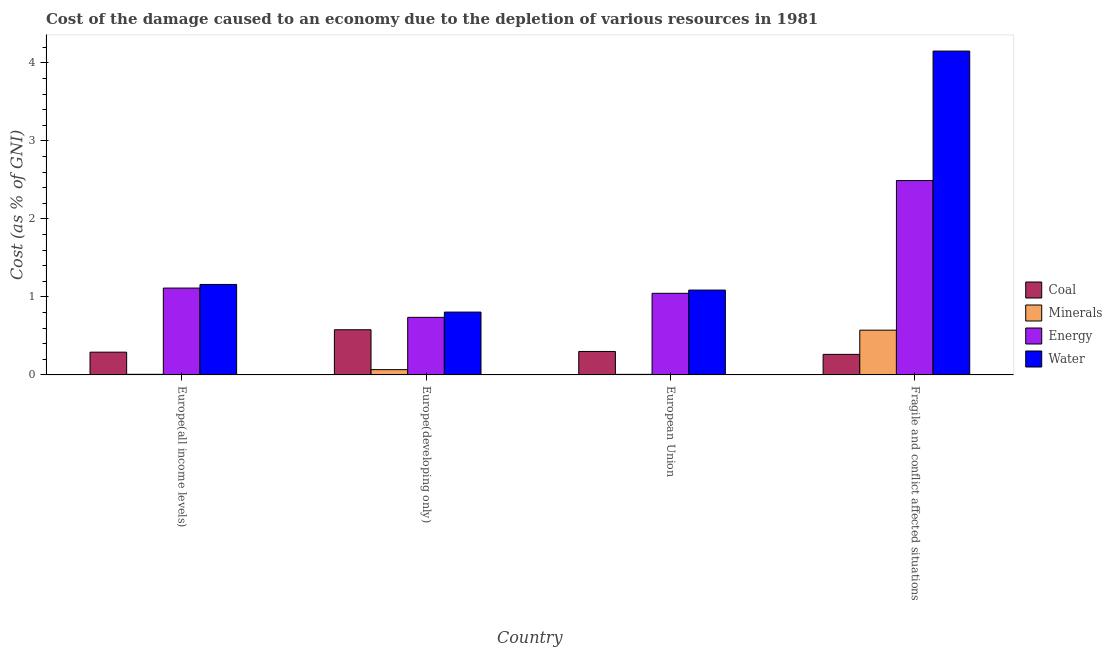How many different coloured bars are there?
Provide a short and direct response. 4. Are the number of bars per tick equal to the number of legend labels?
Keep it short and to the point. Yes. Are the number of bars on each tick of the X-axis equal?
Ensure brevity in your answer.  Yes. How many bars are there on the 1st tick from the left?
Offer a very short reply. 4. What is the label of the 3rd group of bars from the left?
Your answer should be compact. European Union. In how many cases, is the number of bars for a given country not equal to the number of legend labels?
Your answer should be compact. 0. What is the cost of damage due to depletion of coal in Europe(developing only)?
Offer a very short reply. 0.58. Across all countries, what is the maximum cost of damage due to depletion of energy?
Keep it short and to the point. 2.49. Across all countries, what is the minimum cost of damage due to depletion of minerals?
Your answer should be compact. 0.01. In which country was the cost of damage due to depletion of water maximum?
Ensure brevity in your answer.  Fragile and conflict affected situations. In which country was the cost of damage due to depletion of energy minimum?
Give a very brief answer. Europe(developing only). What is the total cost of damage due to depletion of energy in the graph?
Keep it short and to the point. 5.39. What is the difference between the cost of damage due to depletion of coal in Europe(all income levels) and that in Europe(developing only)?
Your response must be concise. -0.29. What is the difference between the cost of damage due to depletion of energy in Europe(developing only) and the cost of damage due to depletion of coal in Fragile and conflict affected situations?
Provide a short and direct response. 0.47. What is the average cost of damage due to depletion of coal per country?
Make the answer very short. 0.36. What is the difference between the cost of damage due to depletion of water and cost of damage due to depletion of energy in European Union?
Give a very brief answer. 0.04. What is the ratio of the cost of damage due to depletion of coal in Europe(all income levels) to that in Fragile and conflict affected situations?
Make the answer very short. 1.11. Is the cost of damage due to depletion of minerals in Europe(developing only) less than that in European Union?
Your response must be concise. No. What is the difference between the highest and the second highest cost of damage due to depletion of water?
Give a very brief answer. 2.99. What is the difference between the highest and the lowest cost of damage due to depletion of coal?
Offer a very short reply. 0.32. Is it the case that in every country, the sum of the cost of damage due to depletion of water and cost of damage due to depletion of coal is greater than the sum of cost of damage due to depletion of minerals and cost of damage due to depletion of energy?
Keep it short and to the point. Yes. What does the 4th bar from the left in European Union represents?
Your answer should be compact. Water. What does the 1st bar from the right in Europe(developing only) represents?
Give a very brief answer. Water. How many bars are there?
Your response must be concise. 16. Are all the bars in the graph horizontal?
Your answer should be compact. No. How many countries are there in the graph?
Give a very brief answer. 4. Are the values on the major ticks of Y-axis written in scientific E-notation?
Provide a short and direct response. No. Does the graph contain any zero values?
Your answer should be compact. No. Does the graph contain grids?
Provide a succinct answer. No. Where does the legend appear in the graph?
Your answer should be compact. Center right. What is the title of the graph?
Offer a very short reply. Cost of the damage caused to an economy due to the depletion of various resources in 1981 . What is the label or title of the X-axis?
Keep it short and to the point. Country. What is the label or title of the Y-axis?
Give a very brief answer. Cost (as % of GNI). What is the Cost (as % of GNI) of Coal in Europe(all income levels)?
Make the answer very short. 0.29. What is the Cost (as % of GNI) in Minerals in Europe(all income levels)?
Your answer should be compact. 0.01. What is the Cost (as % of GNI) in Energy in Europe(all income levels)?
Ensure brevity in your answer.  1.11. What is the Cost (as % of GNI) of Water in Europe(all income levels)?
Give a very brief answer. 1.16. What is the Cost (as % of GNI) of Coal in Europe(developing only)?
Provide a short and direct response. 0.58. What is the Cost (as % of GNI) of Minerals in Europe(developing only)?
Ensure brevity in your answer.  0.07. What is the Cost (as % of GNI) of Energy in Europe(developing only)?
Make the answer very short. 0.74. What is the Cost (as % of GNI) in Water in Europe(developing only)?
Your answer should be very brief. 0.81. What is the Cost (as % of GNI) in Coal in European Union?
Make the answer very short. 0.3. What is the Cost (as % of GNI) in Minerals in European Union?
Provide a succinct answer. 0.01. What is the Cost (as % of GNI) in Energy in European Union?
Ensure brevity in your answer.  1.05. What is the Cost (as % of GNI) of Water in European Union?
Keep it short and to the point. 1.09. What is the Cost (as % of GNI) of Coal in Fragile and conflict affected situations?
Provide a short and direct response. 0.26. What is the Cost (as % of GNI) of Minerals in Fragile and conflict affected situations?
Provide a succinct answer. 0.57. What is the Cost (as % of GNI) in Energy in Fragile and conflict affected situations?
Keep it short and to the point. 2.49. What is the Cost (as % of GNI) of Water in Fragile and conflict affected situations?
Provide a short and direct response. 4.15. Across all countries, what is the maximum Cost (as % of GNI) of Coal?
Keep it short and to the point. 0.58. Across all countries, what is the maximum Cost (as % of GNI) in Minerals?
Your answer should be very brief. 0.57. Across all countries, what is the maximum Cost (as % of GNI) in Energy?
Provide a succinct answer. 2.49. Across all countries, what is the maximum Cost (as % of GNI) of Water?
Give a very brief answer. 4.15. Across all countries, what is the minimum Cost (as % of GNI) of Coal?
Provide a short and direct response. 0.26. Across all countries, what is the minimum Cost (as % of GNI) in Minerals?
Ensure brevity in your answer.  0.01. Across all countries, what is the minimum Cost (as % of GNI) in Energy?
Provide a succinct answer. 0.74. Across all countries, what is the minimum Cost (as % of GNI) in Water?
Give a very brief answer. 0.81. What is the total Cost (as % of GNI) of Coal in the graph?
Your response must be concise. 1.43. What is the total Cost (as % of GNI) in Minerals in the graph?
Offer a terse response. 0.66. What is the total Cost (as % of GNI) in Energy in the graph?
Your answer should be very brief. 5.39. What is the total Cost (as % of GNI) in Water in the graph?
Keep it short and to the point. 7.21. What is the difference between the Cost (as % of GNI) of Coal in Europe(all income levels) and that in Europe(developing only)?
Give a very brief answer. -0.29. What is the difference between the Cost (as % of GNI) of Minerals in Europe(all income levels) and that in Europe(developing only)?
Offer a terse response. -0.06. What is the difference between the Cost (as % of GNI) of Energy in Europe(all income levels) and that in Europe(developing only)?
Your answer should be very brief. 0.38. What is the difference between the Cost (as % of GNI) of Water in Europe(all income levels) and that in Europe(developing only)?
Ensure brevity in your answer.  0.35. What is the difference between the Cost (as % of GNI) of Coal in Europe(all income levels) and that in European Union?
Keep it short and to the point. -0.01. What is the difference between the Cost (as % of GNI) in Minerals in Europe(all income levels) and that in European Union?
Give a very brief answer. 0. What is the difference between the Cost (as % of GNI) of Energy in Europe(all income levels) and that in European Union?
Provide a short and direct response. 0.07. What is the difference between the Cost (as % of GNI) in Water in Europe(all income levels) and that in European Union?
Provide a succinct answer. 0.07. What is the difference between the Cost (as % of GNI) in Coal in Europe(all income levels) and that in Fragile and conflict affected situations?
Offer a very short reply. 0.03. What is the difference between the Cost (as % of GNI) in Minerals in Europe(all income levels) and that in Fragile and conflict affected situations?
Your answer should be very brief. -0.57. What is the difference between the Cost (as % of GNI) of Energy in Europe(all income levels) and that in Fragile and conflict affected situations?
Your answer should be compact. -1.38. What is the difference between the Cost (as % of GNI) of Water in Europe(all income levels) and that in Fragile and conflict affected situations?
Offer a very short reply. -2.99. What is the difference between the Cost (as % of GNI) of Coal in Europe(developing only) and that in European Union?
Your response must be concise. 0.28. What is the difference between the Cost (as % of GNI) in Minerals in Europe(developing only) and that in European Union?
Make the answer very short. 0.06. What is the difference between the Cost (as % of GNI) of Energy in Europe(developing only) and that in European Union?
Keep it short and to the point. -0.31. What is the difference between the Cost (as % of GNI) of Water in Europe(developing only) and that in European Union?
Ensure brevity in your answer.  -0.28. What is the difference between the Cost (as % of GNI) in Coal in Europe(developing only) and that in Fragile and conflict affected situations?
Provide a short and direct response. 0.32. What is the difference between the Cost (as % of GNI) of Minerals in Europe(developing only) and that in Fragile and conflict affected situations?
Offer a very short reply. -0.51. What is the difference between the Cost (as % of GNI) in Energy in Europe(developing only) and that in Fragile and conflict affected situations?
Keep it short and to the point. -1.75. What is the difference between the Cost (as % of GNI) of Water in Europe(developing only) and that in Fragile and conflict affected situations?
Keep it short and to the point. -3.35. What is the difference between the Cost (as % of GNI) of Coal in European Union and that in Fragile and conflict affected situations?
Keep it short and to the point. 0.04. What is the difference between the Cost (as % of GNI) of Minerals in European Union and that in Fragile and conflict affected situations?
Make the answer very short. -0.57. What is the difference between the Cost (as % of GNI) in Energy in European Union and that in Fragile and conflict affected situations?
Your answer should be compact. -1.45. What is the difference between the Cost (as % of GNI) in Water in European Union and that in Fragile and conflict affected situations?
Give a very brief answer. -3.06. What is the difference between the Cost (as % of GNI) in Coal in Europe(all income levels) and the Cost (as % of GNI) in Minerals in Europe(developing only)?
Ensure brevity in your answer.  0.22. What is the difference between the Cost (as % of GNI) in Coal in Europe(all income levels) and the Cost (as % of GNI) in Energy in Europe(developing only)?
Make the answer very short. -0.45. What is the difference between the Cost (as % of GNI) in Coal in Europe(all income levels) and the Cost (as % of GNI) in Water in Europe(developing only)?
Give a very brief answer. -0.51. What is the difference between the Cost (as % of GNI) of Minerals in Europe(all income levels) and the Cost (as % of GNI) of Energy in Europe(developing only)?
Your answer should be compact. -0.73. What is the difference between the Cost (as % of GNI) in Minerals in Europe(all income levels) and the Cost (as % of GNI) in Water in Europe(developing only)?
Give a very brief answer. -0.8. What is the difference between the Cost (as % of GNI) in Energy in Europe(all income levels) and the Cost (as % of GNI) in Water in Europe(developing only)?
Your response must be concise. 0.31. What is the difference between the Cost (as % of GNI) in Coal in Europe(all income levels) and the Cost (as % of GNI) in Minerals in European Union?
Your response must be concise. 0.28. What is the difference between the Cost (as % of GNI) in Coal in Europe(all income levels) and the Cost (as % of GNI) in Energy in European Union?
Your response must be concise. -0.75. What is the difference between the Cost (as % of GNI) in Coal in Europe(all income levels) and the Cost (as % of GNI) in Water in European Union?
Keep it short and to the point. -0.8. What is the difference between the Cost (as % of GNI) of Minerals in Europe(all income levels) and the Cost (as % of GNI) of Energy in European Union?
Your answer should be very brief. -1.04. What is the difference between the Cost (as % of GNI) in Minerals in Europe(all income levels) and the Cost (as % of GNI) in Water in European Union?
Offer a very short reply. -1.08. What is the difference between the Cost (as % of GNI) of Energy in Europe(all income levels) and the Cost (as % of GNI) of Water in European Union?
Provide a short and direct response. 0.03. What is the difference between the Cost (as % of GNI) of Coal in Europe(all income levels) and the Cost (as % of GNI) of Minerals in Fragile and conflict affected situations?
Make the answer very short. -0.28. What is the difference between the Cost (as % of GNI) of Coal in Europe(all income levels) and the Cost (as % of GNI) of Energy in Fragile and conflict affected situations?
Keep it short and to the point. -2.2. What is the difference between the Cost (as % of GNI) in Coal in Europe(all income levels) and the Cost (as % of GNI) in Water in Fragile and conflict affected situations?
Your response must be concise. -3.86. What is the difference between the Cost (as % of GNI) in Minerals in Europe(all income levels) and the Cost (as % of GNI) in Energy in Fragile and conflict affected situations?
Make the answer very short. -2.48. What is the difference between the Cost (as % of GNI) of Minerals in Europe(all income levels) and the Cost (as % of GNI) of Water in Fragile and conflict affected situations?
Keep it short and to the point. -4.14. What is the difference between the Cost (as % of GNI) of Energy in Europe(all income levels) and the Cost (as % of GNI) of Water in Fragile and conflict affected situations?
Provide a short and direct response. -3.04. What is the difference between the Cost (as % of GNI) of Coal in Europe(developing only) and the Cost (as % of GNI) of Minerals in European Union?
Keep it short and to the point. 0.57. What is the difference between the Cost (as % of GNI) of Coal in Europe(developing only) and the Cost (as % of GNI) of Energy in European Union?
Your answer should be very brief. -0.47. What is the difference between the Cost (as % of GNI) in Coal in Europe(developing only) and the Cost (as % of GNI) in Water in European Union?
Your response must be concise. -0.51. What is the difference between the Cost (as % of GNI) of Minerals in Europe(developing only) and the Cost (as % of GNI) of Energy in European Union?
Offer a very short reply. -0.98. What is the difference between the Cost (as % of GNI) in Minerals in Europe(developing only) and the Cost (as % of GNI) in Water in European Union?
Keep it short and to the point. -1.02. What is the difference between the Cost (as % of GNI) in Energy in Europe(developing only) and the Cost (as % of GNI) in Water in European Union?
Offer a terse response. -0.35. What is the difference between the Cost (as % of GNI) in Coal in Europe(developing only) and the Cost (as % of GNI) in Minerals in Fragile and conflict affected situations?
Give a very brief answer. 0.01. What is the difference between the Cost (as % of GNI) in Coal in Europe(developing only) and the Cost (as % of GNI) in Energy in Fragile and conflict affected situations?
Ensure brevity in your answer.  -1.91. What is the difference between the Cost (as % of GNI) in Coal in Europe(developing only) and the Cost (as % of GNI) in Water in Fragile and conflict affected situations?
Offer a terse response. -3.57. What is the difference between the Cost (as % of GNI) in Minerals in Europe(developing only) and the Cost (as % of GNI) in Energy in Fragile and conflict affected situations?
Your answer should be very brief. -2.42. What is the difference between the Cost (as % of GNI) of Minerals in Europe(developing only) and the Cost (as % of GNI) of Water in Fragile and conflict affected situations?
Offer a very short reply. -4.09. What is the difference between the Cost (as % of GNI) of Energy in Europe(developing only) and the Cost (as % of GNI) of Water in Fragile and conflict affected situations?
Make the answer very short. -3.41. What is the difference between the Cost (as % of GNI) of Coal in European Union and the Cost (as % of GNI) of Minerals in Fragile and conflict affected situations?
Your answer should be very brief. -0.27. What is the difference between the Cost (as % of GNI) in Coal in European Union and the Cost (as % of GNI) in Energy in Fragile and conflict affected situations?
Your answer should be very brief. -2.19. What is the difference between the Cost (as % of GNI) of Coal in European Union and the Cost (as % of GNI) of Water in Fragile and conflict affected situations?
Ensure brevity in your answer.  -3.85. What is the difference between the Cost (as % of GNI) in Minerals in European Union and the Cost (as % of GNI) in Energy in Fragile and conflict affected situations?
Keep it short and to the point. -2.49. What is the difference between the Cost (as % of GNI) of Minerals in European Union and the Cost (as % of GNI) of Water in Fragile and conflict affected situations?
Your answer should be compact. -4.15. What is the difference between the Cost (as % of GNI) of Energy in European Union and the Cost (as % of GNI) of Water in Fragile and conflict affected situations?
Offer a very short reply. -3.11. What is the average Cost (as % of GNI) of Coal per country?
Provide a short and direct response. 0.36. What is the average Cost (as % of GNI) in Minerals per country?
Offer a very short reply. 0.16. What is the average Cost (as % of GNI) in Energy per country?
Make the answer very short. 1.35. What is the average Cost (as % of GNI) of Water per country?
Your response must be concise. 1.8. What is the difference between the Cost (as % of GNI) in Coal and Cost (as % of GNI) in Minerals in Europe(all income levels)?
Ensure brevity in your answer.  0.28. What is the difference between the Cost (as % of GNI) in Coal and Cost (as % of GNI) in Energy in Europe(all income levels)?
Make the answer very short. -0.82. What is the difference between the Cost (as % of GNI) of Coal and Cost (as % of GNI) of Water in Europe(all income levels)?
Provide a succinct answer. -0.87. What is the difference between the Cost (as % of GNI) of Minerals and Cost (as % of GNI) of Energy in Europe(all income levels)?
Offer a very short reply. -1.11. What is the difference between the Cost (as % of GNI) in Minerals and Cost (as % of GNI) in Water in Europe(all income levels)?
Your answer should be compact. -1.15. What is the difference between the Cost (as % of GNI) in Energy and Cost (as % of GNI) in Water in Europe(all income levels)?
Ensure brevity in your answer.  -0.05. What is the difference between the Cost (as % of GNI) of Coal and Cost (as % of GNI) of Minerals in Europe(developing only)?
Keep it short and to the point. 0.51. What is the difference between the Cost (as % of GNI) of Coal and Cost (as % of GNI) of Energy in Europe(developing only)?
Give a very brief answer. -0.16. What is the difference between the Cost (as % of GNI) in Coal and Cost (as % of GNI) in Water in Europe(developing only)?
Keep it short and to the point. -0.23. What is the difference between the Cost (as % of GNI) in Minerals and Cost (as % of GNI) in Energy in Europe(developing only)?
Make the answer very short. -0.67. What is the difference between the Cost (as % of GNI) in Minerals and Cost (as % of GNI) in Water in Europe(developing only)?
Your answer should be compact. -0.74. What is the difference between the Cost (as % of GNI) in Energy and Cost (as % of GNI) in Water in Europe(developing only)?
Offer a terse response. -0.07. What is the difference between the Cost (as % of GNI) in Coal and Cost (as % of GNI) in Minerals in European Union?
Your answer should be compact. 0.29. What is the difference between the Cost (as % of GNI) in Coal and Cost (as % of GNI) in Energy in European Union?
Provide a short and direct response. -0.75. What is the difference between the Cost (as % of GNI) in Coal and Cost (as % of GNI) in Water in European Union?
Your answer should be very brief. -0.79. What is the difference between the Cost (as % of GNI) in Minerals and Cost (as % of GNI) in Energy in European Union?
Keep it short and to the point. -1.04. What is the difference between the Cost (as % of GNI) in Minerals and Cost (as % of GNI) in Water in European Union?
Make the answer very short. -1.08. What is the difference between the Cost (as % of GNI) of Energy and Cost (as % of GNI) of Water in European Union?
Offer a very short reply. -0.04. What is the difference between the Cost (as % of GNI) in Coal and Cost (as % of GNI) in Minerals in Fragile and conflict affected situations?
Your response must be concise. -0.31. What is the difference between the Cost (as % of GNI) of Coal and Cost (as % of GNI) of Energy in Fragile and conflict affected situations?
Offer a very short reply. -2.23. What is the difference between the Cost (as % of GNI) in Coal and Cost (as % of GNI) in Water in Fragile and conflict affected situations?
Give a very brief answer. -3.89. What is the difference between the Cost (as % of GNI) of Minerals and Cost (as % of GNI) of Energy in Fragile and conflict affected situations?
Give a very brief answer. -1.92. What is the difference between the Cost (as % of GNI) of Minerals and Cost (as % of GNI) of Water in Fragile and conflict affected situations?
Offer a terse response. -3.58. What is the difference between the Cost (as % of GNI) of Energy and Cost (as % of GNI) of Water in Fragile and conflict affected situations?
Give a very brief answer. -1.66. What is the ratio of the Cost (as % of GNI) of Coal in Europe(all income levels) to that in Europe(developing only)?
Your response must be concise. 0.5. What is the ratio of the Cost (as % of GNI) in Minerals in Europe(all income levels) to that in Europe(developing only)?
Make the answer very short. 0.12. What is the ratio of the Cost (as % of GNI) in Energy in Europe(all income levels) to that in Europe(developing only)?
Provide a short and direct response. 1.51. What is the ratio of the Cost (as % of GNI) in Water in Europe(all income levels) to that in Europe(developing only)?
Give a very brief answer. 1.44. What is the ratio of the Cost (as % of GNI) in Coal in Europe(all income levels) to that in European Union?
Give a very brief answer. 0.97. What is the ratio of the Cost (as % of GNI) in Minerals in Europe(all income levels) to that in European Union?
Give a very brief answer. 1.09. What is the ratio of the Cost (as % of GNI) of Energy in Europe(all income levels) to that in European Union?
Make the answer very short. 1.06. What is the ratio of the Cost (as % of GNI) of Water in Europe(all income levels) to that in European Union?
Offer a very short reply. 1.07. What is the ratio of the Cost (as % of GNI) of Coal in Europe(all income levels) to that in Fragile and conflict affected situations?
Offer a very short reply. 1.11. What is the ratio of the Cost (as % of GNI) in Minerals in Europe(all income levels) to that in Fragile and conflict affected situations?
Your response must be concise. 0.01. What is the ratio of the Cost (as % of GNI) of Energy in Europe(all income levels) to that in Fragile and conflict affected situations?
Provide a short and direct response. 0.45. What is the ratio of the Cost (as % of GNI) in Water in Europe(all income levels) to that in Fragile and conflict affected situations?
Offer a terse response. 0.28. What is the ratio of the Cost (as % of GNI) of Coal in Europe(developing only) to that in European Union?
Make the answer very short. 1.93. What is the ratio of the Cost (as % of GNI) in Minerals in Europe(developing only) to that in European Union?
Provide a short and direct response. 9.4. What is the ratio of the Cost (as % of GNI) in Energy in Europe(developing only) to that in European Union?
Offer a terse response. 0.71. What is the ratio of the Cost (as % of GNI) of Water in Europe(developing only) to that in European Union?
Provide a short and direct response. 0.74. What is the ratio of the Cost (as % of GNI) in Coal in Europe(developing only) to that in Fragile and conflict affected situations?
Your answer should be compact. 2.2. What is the ratio of the Cost (as % of GNI) in Minerals in Europe(developing only) to that in Fragile and conflict affected situations?
Ensure brevity in your answer.  0.12. What is the ratio of the Cost (as % of GNI) in Energy in Europe(developing only) to that in Fragile and conflict affected situations?
Keep it short and to the point. 0.3. What is the ratio of the Cost (as % of GNI) of Water in Europe(developing only) to that in Fragile and conflict affected situations?
Offer a terse response. 0.19. What is the ratio of the Cost (as % of GNI) of Coal in European Union to that in Fragile and conflict affected situations?
Make the answer very short. 1.14. What is the ratio of the Cost (as % of GNI) in Minerals in European Union to that in Fragile and conflict affected situations?
Make the answer very short. 0.01. What is the ratio of the Cost (as % of GNI) in Energy in European Union to that in Fragile and conflict affected situations?
Your answer should be compact. 0.42. What is the ratio of the Cost (as % of GNI) in Water in European Union to that in Fragile and conflict affected situations?
Ensure brevity in your answer.  0.26. What is the difference between the highest and the second highest Cost (as % of GNI) in Coal?
Offer a very short reply. 0.28. What is the difference between the highest and the second highest Cost (as % of GNI) of Minerals?
Provide a succinct answer. 0.51. What is the difference between the highest and the second highest Cost (as % of GNI) of Energy?
Offer a very short reply. 1.38. What is the difference between the highest and the second highest Cost (as % of GNI) in Water?
Offer a very short reply. 2.99. What is the difference between the highest and the lowest Cost (as % of GNI) in Coal?
Your answer should be compact. 0.32. What is the difference between the highest and the lowest Cost (as % of GNI) of Minerals?
Give a very brief answer. 0.57. What is the difference between the highest and the lowest Cost (as % of GNI) of Energy?
Give a very brief answer. 1.75. What is the difference between the highest and the lowest Cost (as % of GNI) of Water?
Give a very brief answer. 3.35. 